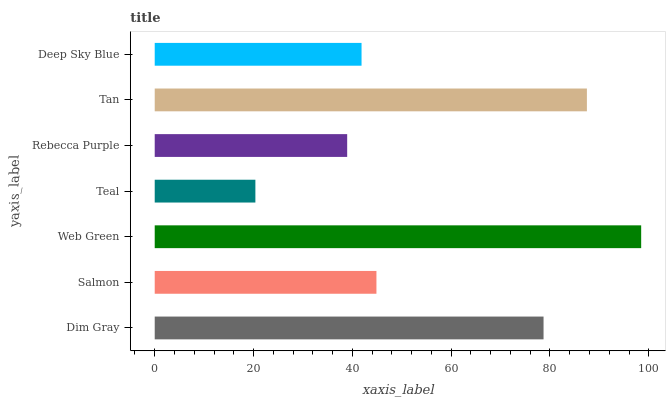Is Teal the minimum?
Answer yes or no. Yes. Is Web Green the maximum?
Answer yes or no. Yes. Is Salmon the minimum?
Answer yes or no. No. Is Salmon the maximum?
Answer yes or no. No. Is Dim Gray greater than Salmon?
Answer yes or no. Yes. Is Salmon less than Dim Gray?
Answer yes or no. Yes. Is Salmon greater than Dim Gray?
Answer yes or no. No. Is Dim Gray less than Salmon?
Answer yes or no. No. Is Salmon the high median?
Answer yes or no. Yes. Is Salmon the low median?
Answer yes or no. Yes. Is Rebecca Purple the high median?
Answer yes or no. No. Is Rebecca Purple the low median?
Answer yes or no. No. 